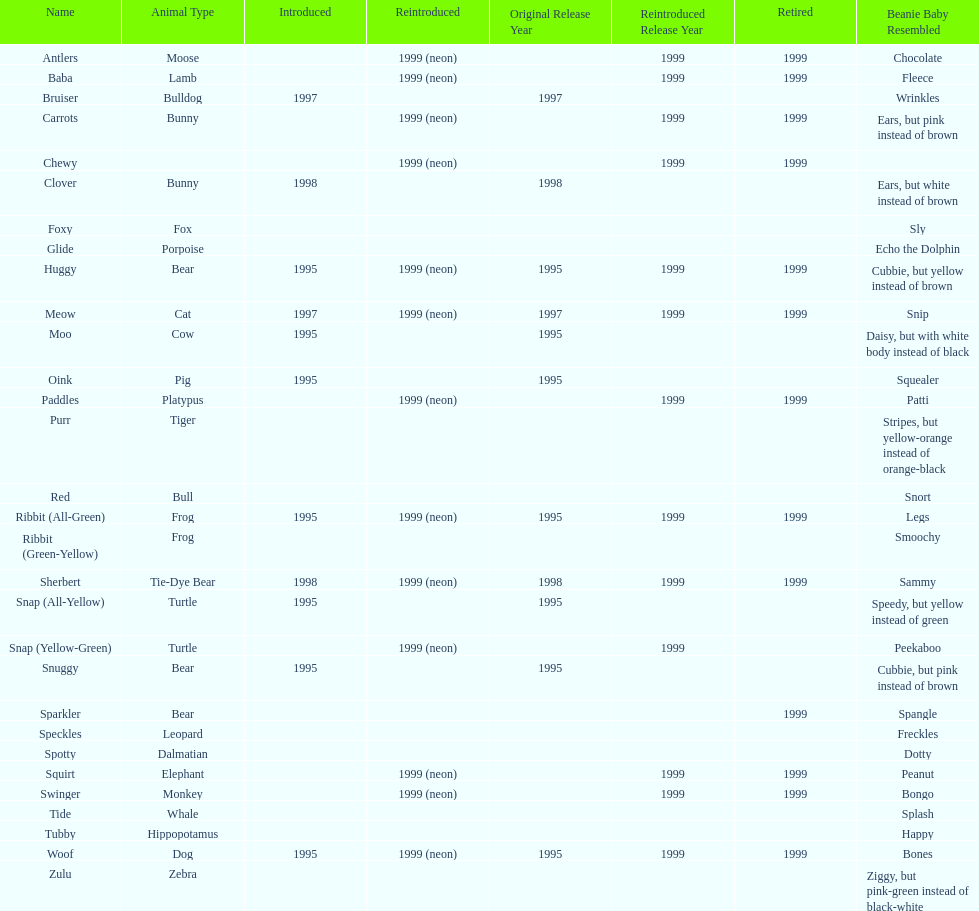How many total pillow pals were both reintroduced and retired in 1999? 12. 